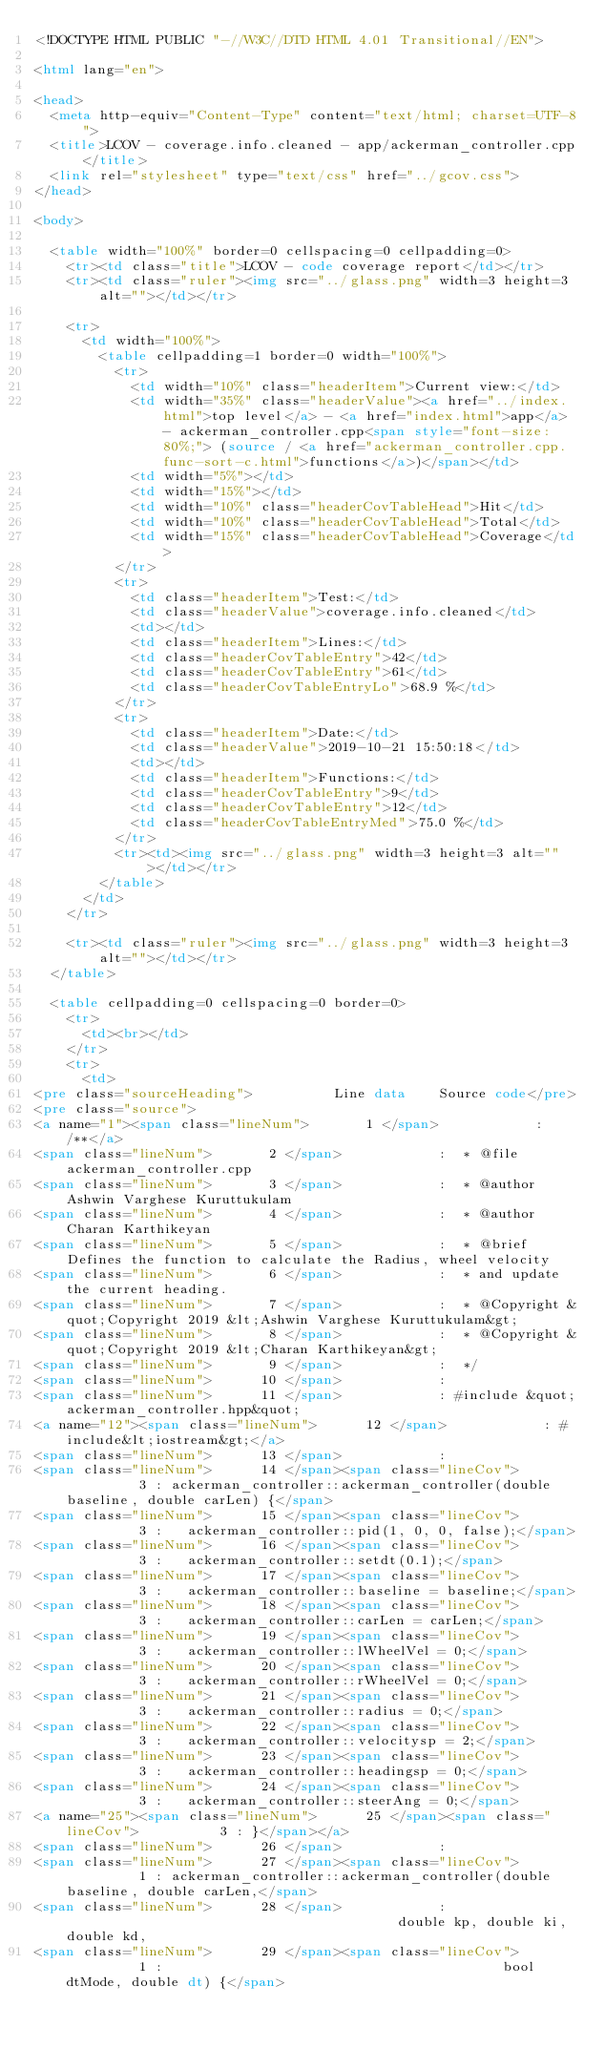Convert code to text. <code><loc_0><loc_0><loc_500><loc_500><_HTML_><!DOCTYPE HTML PUBLIC "-//W3C//DTD HTML 4.01 Transitional//EN">

<html lang="en">

<head>
  <meta http-equiv="Content-Type" content="text/html; charset=UTF-8">
  <title>LCOV - coverage.info.cleaned - app/ackerman_controller.cpp</title>
  <link rel="stylesheet" type="text/css" href="../gcov.css">
</head>

<body>

  <table width="100%" border=0 cellspacing=0 cellpadding=0>
    <tr><td class="title">LCOV - code coverage report</td></tr>
    <tr><td class="ruler"><img src="../glass.png" width=3 height=3 alt=""></td></tr>

    <tr>
      <td width="100%">
        <table cellpadding=1 border=0 width="100%">
          <tr>
            <td width="10%" class="headerItem">Current view:</td>
            <td width="35%" class="headerValue"><a href="../index.html">top level</a> - <a href="index.html">app</a> - ackerman_controller.cpp<span style="font-size: 80%;"> (source / <a href="ackerman_controller.cpp.func-sort-c.html">functions</a>)</span></td>
            <td width="5%"></td>
            <td width="15%"></td>
            <td width="10%" class="headerCovTableHead">Hit</td>
            <td width="10%" class="headerCovTableHead">Total</td>
            <td width="15%" class="headerCovTableHead">Coverage</td>
          </tr>
          <tr>
            <td class="headerItem">Test:</td>
            <td class="headerValue">coverage.info.cleaned</td>
            <td></td>
            <td class="headerItem">Lines:</td>
            <td class="headerCovTableEntry">42</td>
            <td class="headerCovTableEntry">61</td>
            <td class="headerCovTableEntryLo">68.9 %</td>
          </tr>
          <tr>
            <td class="headerItem">Date:</td>
            <td class="headerValue">2019-10-21 15:50:18</td>
            <td></td>
            <td class="headerItem">Functions:</td>
            <td class="headerCovTableEntry">9</td>
            <td class="headerCovTableEntry">12</td>
            <td class="headerCovTableEntryMed">75.0 %</td>
          </tr>
          <tr><td><img src="../glass.png" width=3 height=3 alt=""></td></tr>
        </table>
      </td>
    </tr>

    <tr><td class="ruler"><img src="../glass.png" width=3 height=3 alt=""></td></tr>
  </table>

  <table cellpadding=0 cellspacing=0 border=0>
    <tr>
      <td><br></td>
    </tr>
    <tr>
      <td>
<pre class="sourceHeading">          Line data    Source code</pre>
<pre class="source">
<a name="1"><span class="lineNum">       1 </span>            : /**</a>
<span class="lineNum">       2 </span>            :  * @file ackerman_controller.cpp
<span class="lineNum">       3 </span>            :  * @author Ashwin Varghese Kuruttukulam
<span class="lineNum">       4 </span>            :  * @author Charan Karthikeyan
<span class="lineNum">       5 </span>            :  * @brief Defines the function to calculate the Radius, wheel velocity
<span class="lineNum">       6 </span>            :  * and update the current heading.
<span class="lineNum">       7 </span>            :  * @Copyright &quot;Copyright 2019 &lt;Ashwin Varghese Kuruttukulam&gt;
<span class="lineNum">       8 </span>            :  * @Copyright &quot;Copyright 2019 &lt;Charan Karthikeyan&gt;
<span class="lineNum">       9 </span>            :  */
<span class="lineNum">      10 </span>            : 
<span class="lineNum">      11 </span>            : #include &quot;ackerman_controller.hpp&quot;
<a name="12"><span class="lineNum">      12 </span>            : #include&lt;iostream&gt;</a>
<span class="lineNum">      13 </span>            : 
<span class="lineNum">      14 </span><span class="lineCov">          3 : ackerman_controller::ackerman_controller(double baseline, double carLen) {</span>
<span class="lineNum">      15 </span><span class="lineCov">          3 :   ackerman_controller::pid(1, 0, 0, false);</span>
<span class="lineNum">      16 </span><span class="lineCov">          3 :   ackerman_controller::setdt(0.1);</span>
<span class="lineNum">      17 </span><span class="lineCov">          3 :   ackerman_controller::baseline = baseline;</span>
<span class="lineNum">      18 </span><span class="lineCov">          3 :   ackerman_controller::carLen = carLen;</span>
<span class="lineNum">      19 </span><span class="lineCov">          3 :   ackerman_controller::lWheelVel = 0;</span>
<span class="lineNum">      20 </span><span class="lineCov">          3 :   ackerman_controller::rWheelVel = 0;</span>
<span class="lineNum">      21 </span><span class="lineCov">          3 :   ackerman_controller::radius = 0;</span>
<span class="lineNum">      22 </span><span class="lineCov">          3 :   ackerman_controller::velocitysp = 2;</span>
<span class="lineNum">      23 </span><span class="lineCov">          3 :   ackerman_controller::headingsp = 0;</span>
<span class="lineNum">      24 </span><span class="lineCov">          3 :   ackerman_controller::steerAng = 0;</span>
<a name="25"><span class="lineNum">      25 </span><span class="lineCov">          3 : }</span></a>
<span class="lineNum">      26 </span>            : 
<span class="lineNum">      27 </span><span class="lineCov">          1 : ackerman_controller::ackerman_controller(double baseline, double carLen,</span>
<span class="lineNum">      28 </span>            :                                          double kp, double ki, double kd,
<span class="lineNum">      29 </span><span class="lineCov">          1 :                                          bool dtMode, double dt) {</span></code> 